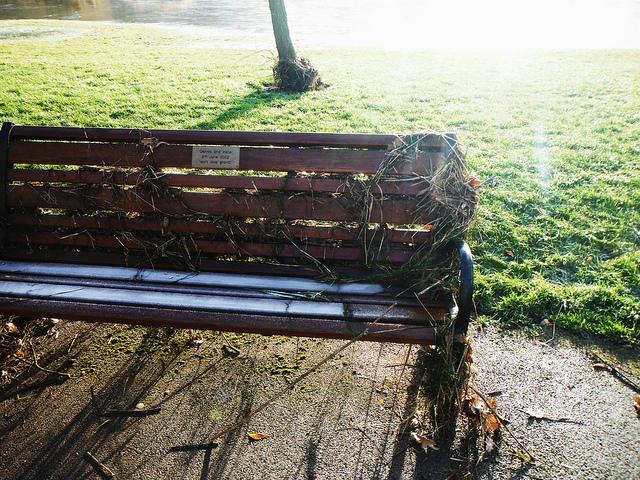Is it possible to read the writing on the sign?
Short answer required. No. Is this area well maintained?
Keep it brief. No. What is tangled in the bench?
Keep it brief. Vine. 